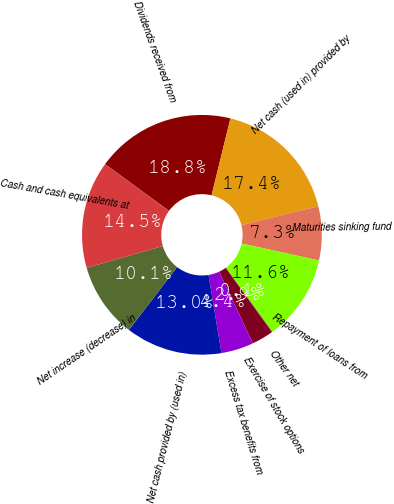<chart> <loc_0><loc_0><loc_500><loc_500><pie_chart><fcel>Dividends received from<fcel>Net cash (used in) provided by<fcel>Maturities sinking fund<fcel>Repayment of loans from<fcel>Other net<fcel>Exercise of stock options<fcel>Excess tax benefits from<fcel>Net cash provided by (used in)<fcel>Net increase (decrease) in<fcel>Cash and cash equivalents at<nl><fcel>18.79%<fcel>17.35%<fcel>7.26%<fcel>11.58%<fcel>0.06%<fcel>2.94%<fcel>4.38%<fcel>13.03%<fcel>10.14%<fcel>14.47%<nl></chart> 